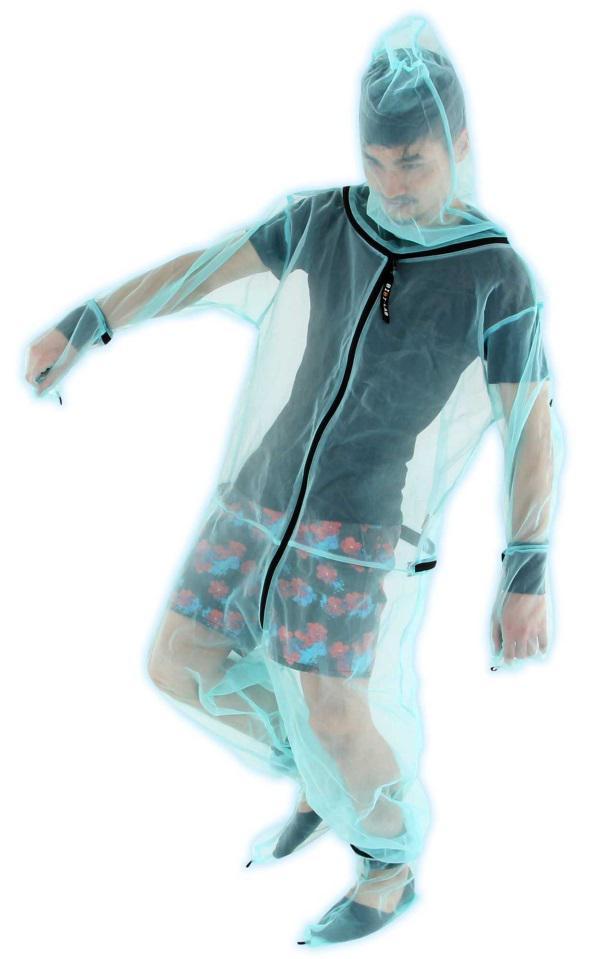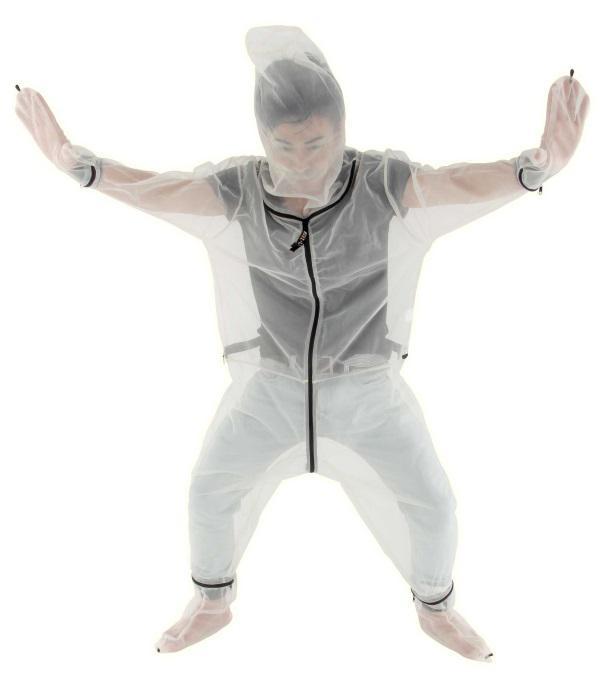The first image is the image on the left, the second image is the image on the right. Evaluate the accuracy of this statement regarding the images: "An image shows a dark-skinned human baby surrounded by netting.". Is it true? Answer yes or no. No. The first image is the image on the left, the second image is the image on the right. Analyze the images presented: Is the assertion "A net is set up over a bed in one of the images." valid? Answer yes or no. No. 